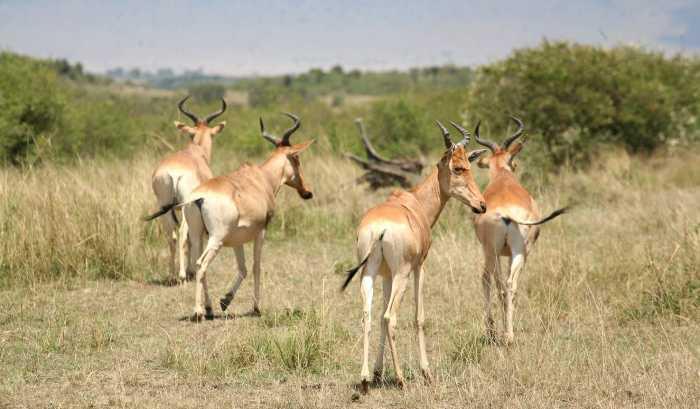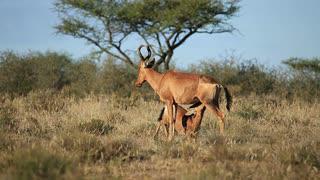The first image is the image on the left, the second image is the image on the right. Evaluate the accuracy of this statement regarding the images: "The left image features more antelopes in the foreground than the right image.". Is it true? Answer yes or no. Yes. 